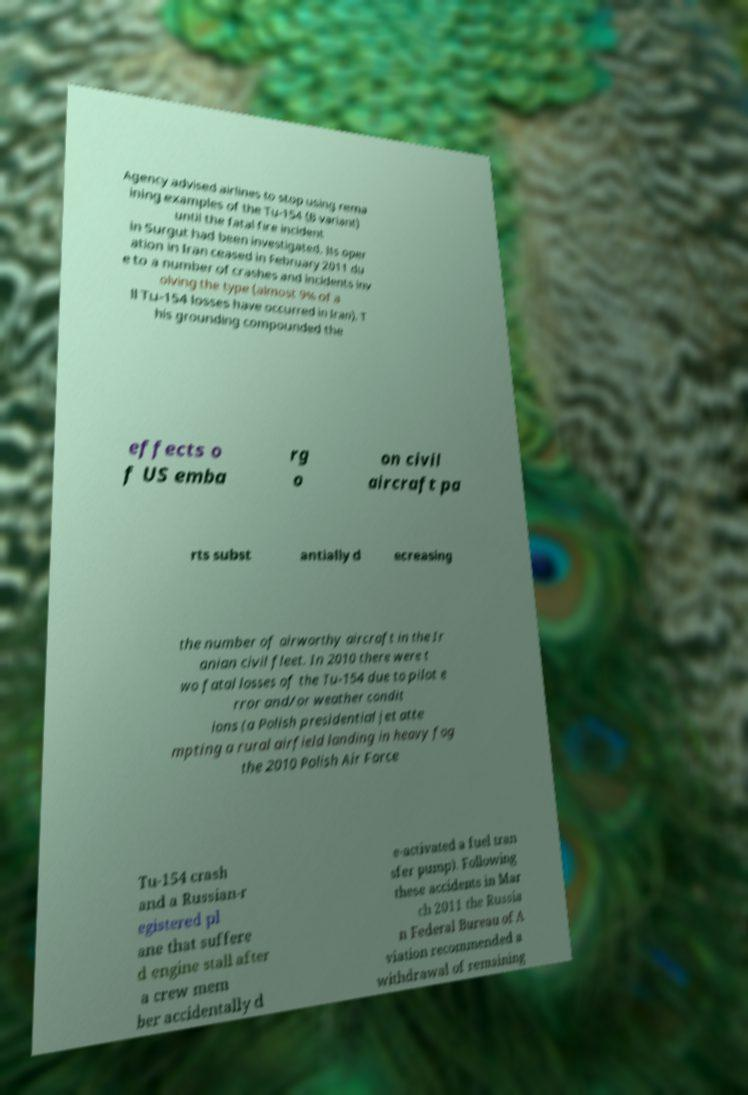For documentation purposes, I need the text within this image transcribed. Could you provide that? Agency advised airlines to stop using rema ining examples of the Tu-154 (B variant) until the fatal fire incident in Surgut had been investigated. Its oper ation in Iran ceased in February 2011 du e to a number of crashes and incidents inv olving the type (almost 9% of a ll Tu-154 losses have occurred in Iran). T his grounding compounded the effects o f US emba rg o on civil aircraft pa rts subst antially d ecreasing the number of airworthy aircraft in the Ir anian civil fleet. In 2010 there were t wo fatal losses of the Tu-154 due to pilot e rror and/or weather condit ions (a Polish presidential jet atte mpting a rural airfield landing in heavy fog the 2010 Polish Air Force Tu-154 crash and a Russian-r egistered pl ane that suffere d engine stall after a crew mem ber accidentally d e-activated a fuel tran sfer pump). Following these accidents in Mar ch 2011 the Russia n Federal Bureau of A viation recommended a withdrawal of remaining 